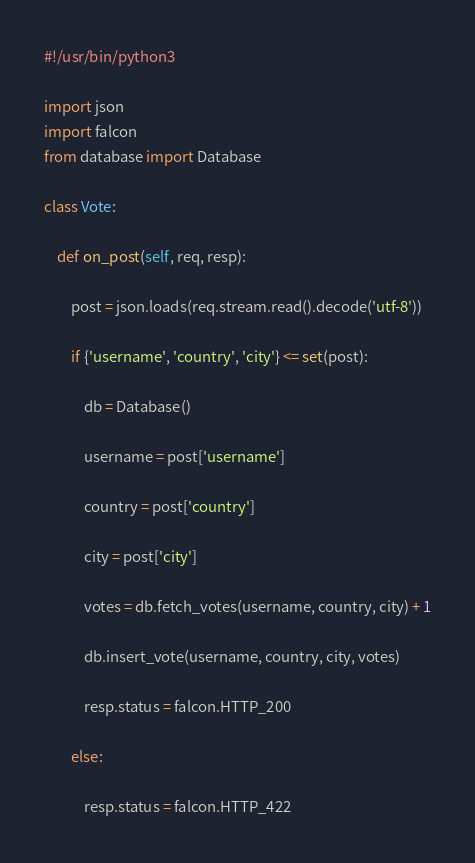Convert code to text. <code><loc_0><loc_0><loc_500><loc_500><_Python_>#!/usr/bin/python3

import json
import falcon
from database import Database

class Vote:

    def on_post(self, req, resp):

        post = json.loads(req.stream.read().decode('utf-8'))

        if {'username', 'country', 'city'} <= set(post):

            db = Database()

            username = post['username']

            country = post['country']

            city = post['city']

            votes = db.fetch_votes(username, country, city) + 1

            db.insert_vote(username, country, city, votes)

            resp.status = falcon.HTTP_200

        else:

            resp.status = falcon.HTTP_422
</code> 